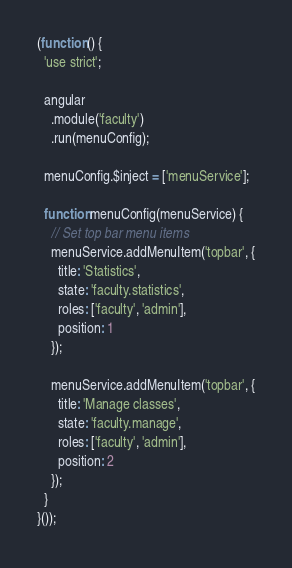Convert code to text. <code><loc_0><loc_0><loc_500><loc_500><_JavaScript_>(function () {
  'use strict';

  angular
    .module('faculty')
    .run(menuConfig);

  menuConfig.$inject = ['menuService'];

  function menuConfig(menuService) {
    // Set top bar menu items
    menuService.addMenuItem('topbar', {
      title: 'Statistics',
      state: 'faculty.statistics',
      roles: ['faculty', 'admin'],
      position: 1
    });

    menuService.addMenuItem('topbar', {
      title: 'Manage classes',
      state: 'faculty.manage',
      roles: ['faculty', 'admin'],
      position: 2
    });
  }
}());
</code> 